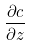<formula> <loc_0><loc_0><loc_500><loc_500>\frac { \partial c } { \partial z }</formula> 